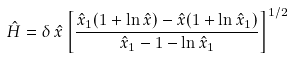<formula> <loc_0><loc_0><loc_500><loc_500>\hat { H } = \delta \, \hat { x } \left [ \frac { \hat { x } _ { 1 } ( 1 + \ln \hat { x } ) - \hat { x } ( 1 + \ln \hat { x } _ { 1 } ) } { \hat { x } _ { 1 } - 1 - \ln \hat { x } _ { 1 } } \right ] ^ { 1 / 2 }</formula> 